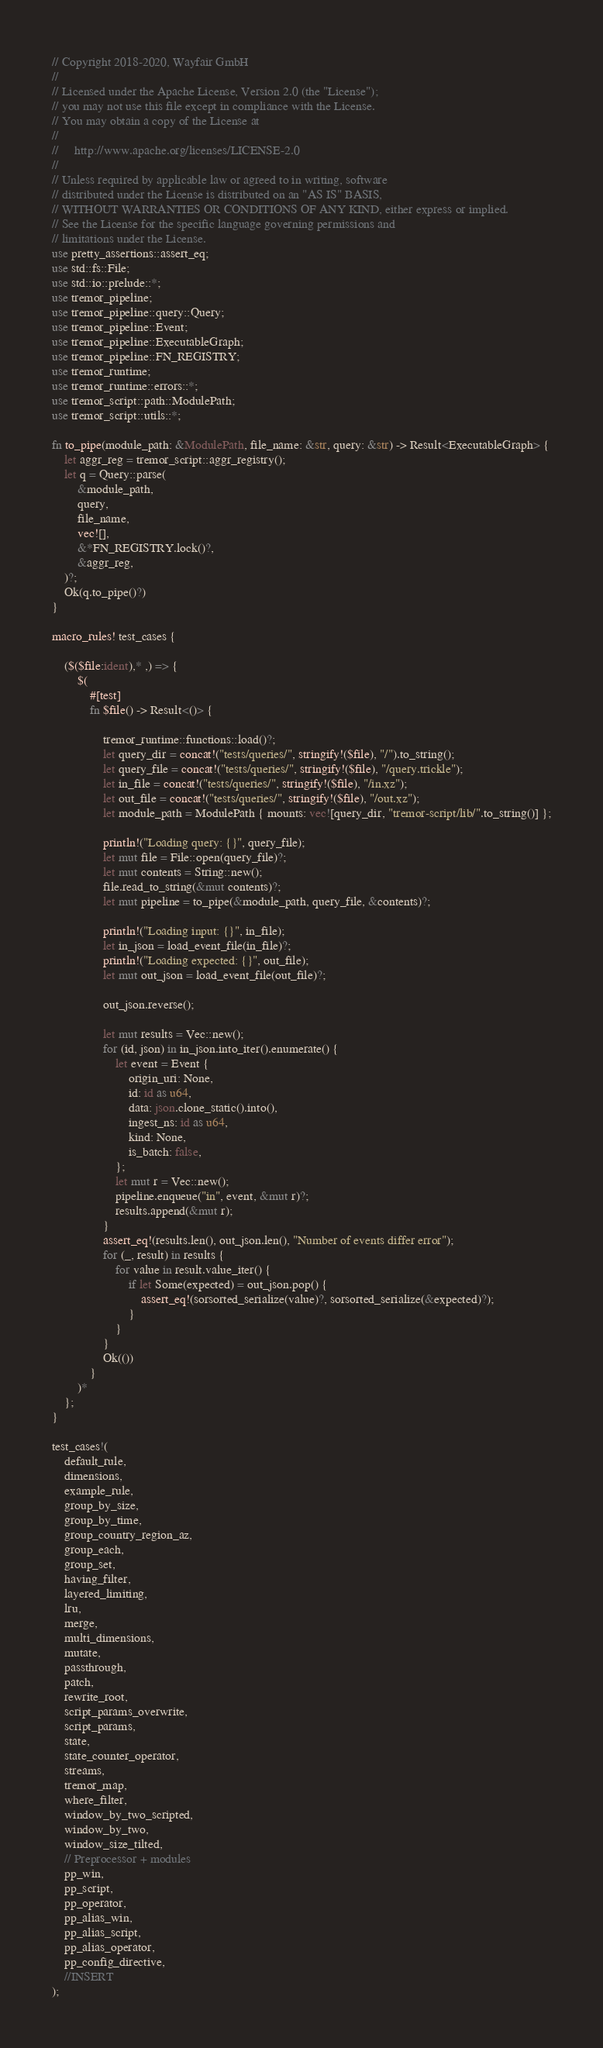<code> <loc_0><loc_0><loc_500><loc_500><_Rust_>// Copyright 2018-2020, Wayfair GmbH
//
// Licensed under the Apache License, Version 2.0 (the "License");
// you may not use this file except in compliance with the License.
// You may obtain a copy of the License at
//
//     http://www.apache.org/licenses/LICENSE-2.0
//
// Unless required by applicable law or agreed to in writing, software
// distributed under the License is distributed on an "AS IS" BASIS,
// WITHOUT WARRANTIES OR CONDITIONS OF ANY KIND, either express or implied.
// See the License for the specific language governing permissions and
// limitations under the License.
use pretty_assertions::assert_eq;
use std::fs::File;
use std::io::prelude::*;
use tremor_pipeline;
use tremor_pipeline::query::Query;
use tremor_pipeline::Event;
use tremor_pipeline::ExecutableGraph;
use tremor_pipeline::FN_REGISTRY;
use tremor_runtime;
use tremor_runtime::errors::*;
use tremor_script::path::ModulePath;
use tremor_script::utils::*;

fn to_pipe(module_path: &ModulePath, file_name: &str, query: &str) -> Result<ExecutableGraph> {
    let aggr_reg = tremor_script::aggr_registry();
    let q = Query::parse(
        &module_path,
        query,
        file_name,
        vec![],
        &*FN_REGISTRY.lock()?,
        &aggr_reg,
    )?;
    Ok(q.to_pipe()?)
}

macro_rules! test_cases {

    ($($file:ident),* ,) => {
        $(
            #[test]
            fn $file() -> Result<()> {

                tremor_runtime::functions::load()?;
                let query_dir = concat!("tests/queries/", stringify!($file), "/").to_string();
                let query_file = concat!("tests/queries/", stringify!($file), "/query.trickle");
                let in_file = concat!("tests/queries/", stringify!($file), "/in.xz");
                let out_file = concat!("tests/queries/", stringify!($file), "/out.xz");
                let module_path = ModulePath { mounts: vec![query_dir, "tremor-script/lib/".to_string()] };

                println!("Loading query: {}", query_file);
                let mut file = File::open(query_file)?;
                let mut contents = String::new();
                file.read_to_string(&mut contents)?;
                let mut pipeline = to_pipe(&module_path, query_file, &contents)?;

                println!("Loading input: {}", in_file);
                let in_json = load_event_file(in_file)?;
                println!("Loading expected: {}", out_file);
                let mut out_json = load_event_file(out_file)?;

                out_json.reverse();

                let mut results = Vec::new();
                for (id, json) in in_json.into_iter().enumerate() {
                    let event = Event {
                        origin_uri: None,
                        id: id as u64,
                        data: json.clone_static().into(),
                        ingest_ns: id as u64,
                        kind: None,
                        is_batch: false,
                    };
                    let mut r = Vec::new();
                    pipeline.enqueue("in", event, &mut r)?;
                    results.append(&mut r);
                }
                assert_eq!(results.len(), out_json.len(), "Number of events differ error");
                for (_, result) in results {
                    for value in result.value_iter() {
                        if let Some(expected) = out_json.pop() {
                            assert_eq!(sorsorted_serialize(value)?, sorsorted_serialize(&expected)?);
                        }
                    }
                }
                Ok(())
            }
        )*
    };
}

test_cases!(
    default_rule,
    dimensions,
    example_rule,
    group_by_size,
    group_by_time,
    group_country_region_az,
    group_each,
    group_set,
    having_filter,
    layered_limiting,
    lru,
    merge,
    multi_dimensions,
    mutate,
    passthrough,
    patch,
    rewrite_root,
    script_params_overwrite,
    script_params,
    state,
    state_counter_operator,
    streams,
    tremor_map,
    where_filter,
    window_by_two_scripted,
    window_by_two,
    window_size_tilted,
    // Preprocessor + modules
    pp_win,
    pp_script,
    pp_operator,
    pp_alias_win,
    pp_alias_script,
    pp_alias_operator,
    pp_config_directive,
    //INSERT
);
</code> 